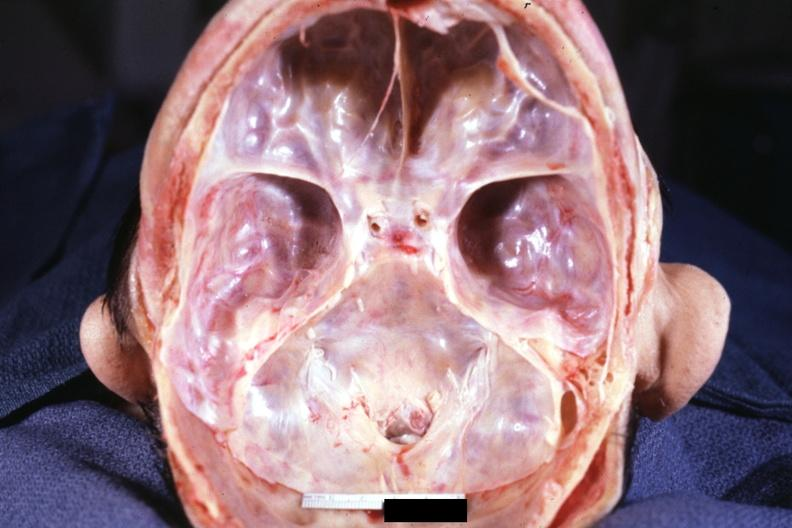does this image show stenosis of foramen magnum due to subluxation of atlas vertebra case 31?
Answer the question using a single word or phrase. Yes 